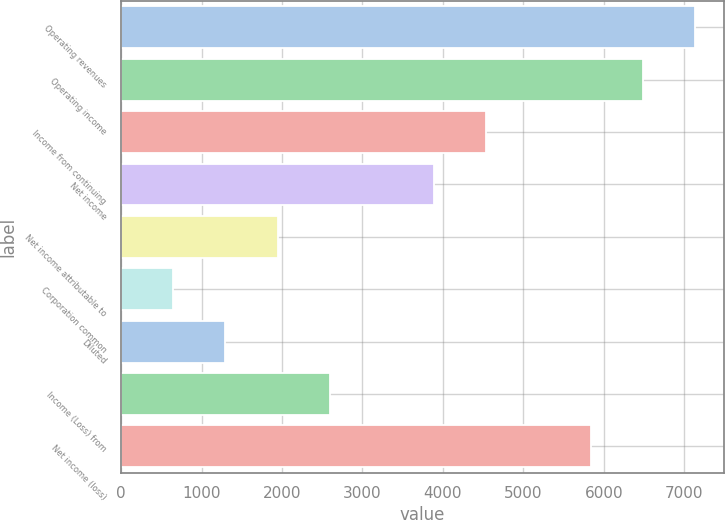Convert chart to OTSL. <chart><loc_0><loc_0><loc_500><loc_500><bar_chart><fcel>Operating revenues<fcel>Operating income<fcel>Income from continuing<fcel>Net income<fcel>Net income attributable to<fcel>Corporation common<fcel>Diluted<fcel>Income (Loss) from<fcel>Net income (loss)<nl><fcel>7130.13<fcel>6481.96<fcel>4537.45<fcel>3889.28<fcel>1944.77<fcel>648.43<fcel>1296.6<fcel>2592.94<fcel>5833.79<nl></chart> 